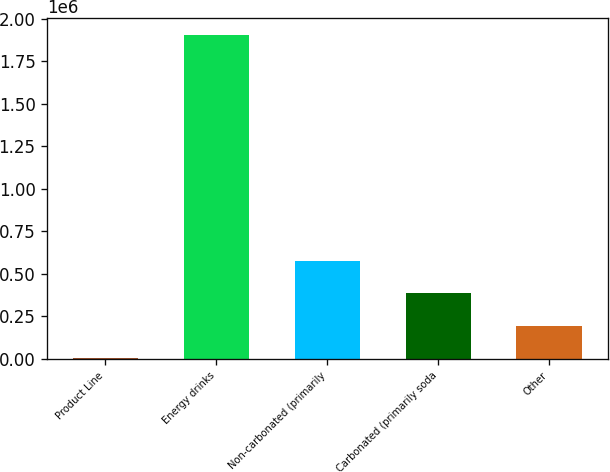Convert chart. <chart><loc_0><loc_0><loc_500><loc_500><bar_chart><fcel>Product Line<fcel>Energy drinks<fcel>Non-carbonated (primarily<fcel>Carbonated (primarily soda<fcel>Other<nl><fcel>2012<fcel>1.90624e+06<fcel>573279<fcel>382857<fcel>192434<nl></chart> 